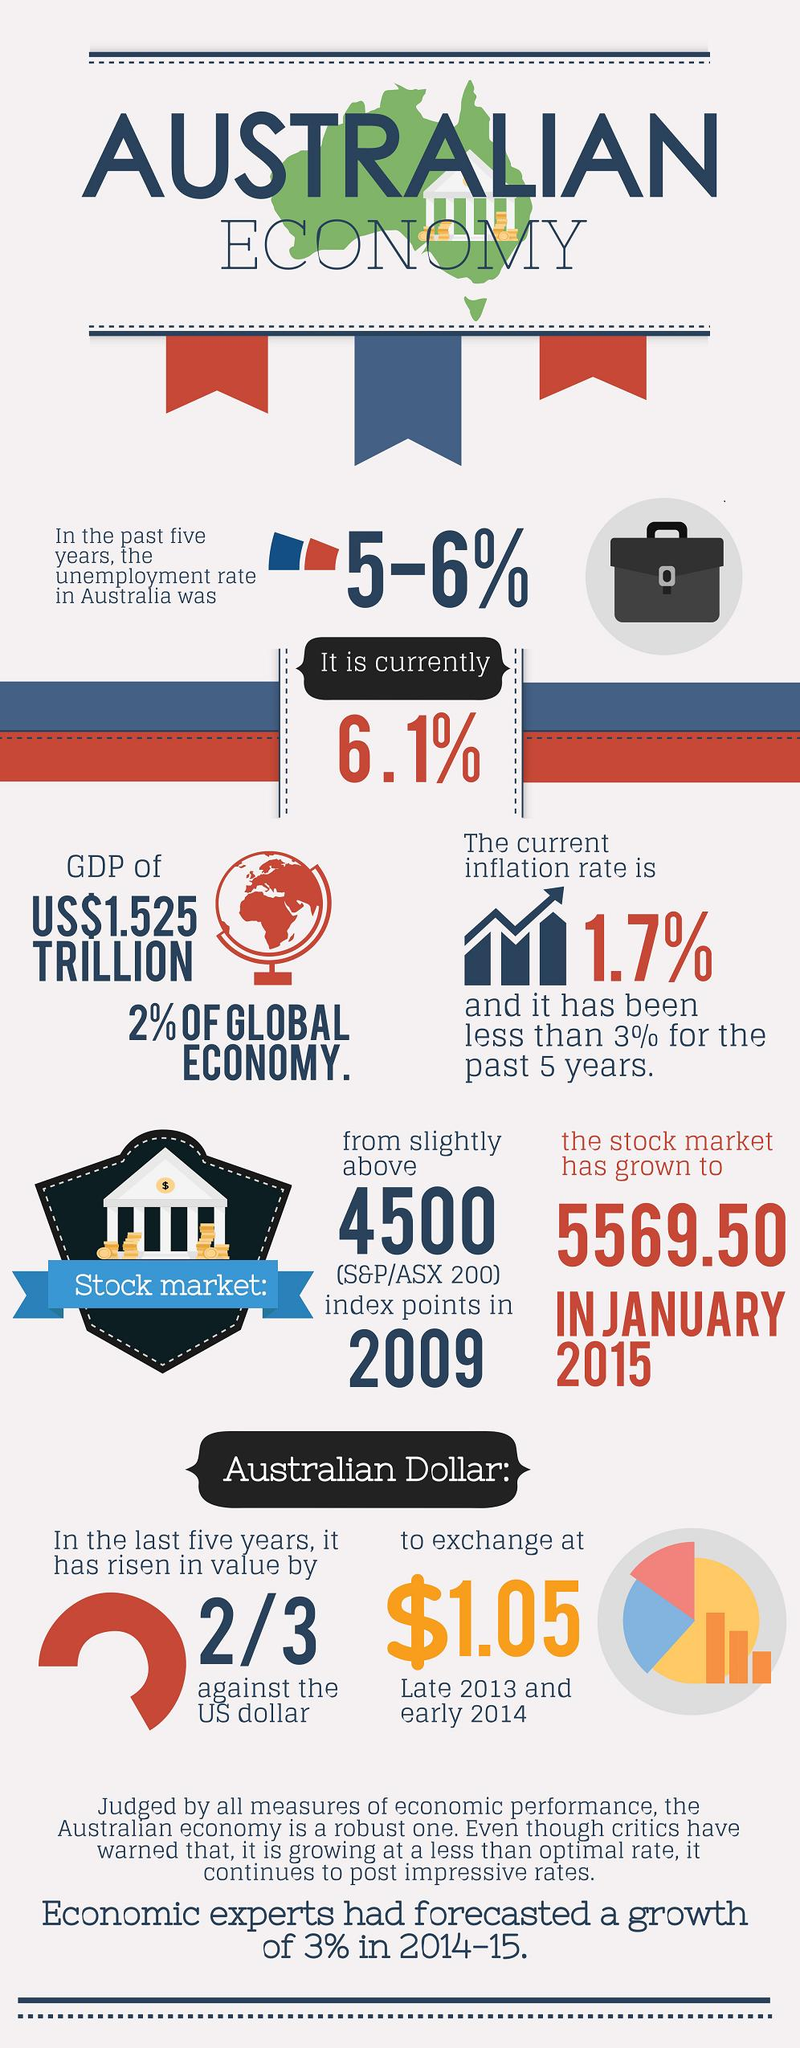Outline some significant characteristics in this image. On January 1st, 2015, the S&P/ASX 200 index of the Australian stock market reached a value of 5569.50. As of the current time, the inflation rate in Australia is 1.7%. 